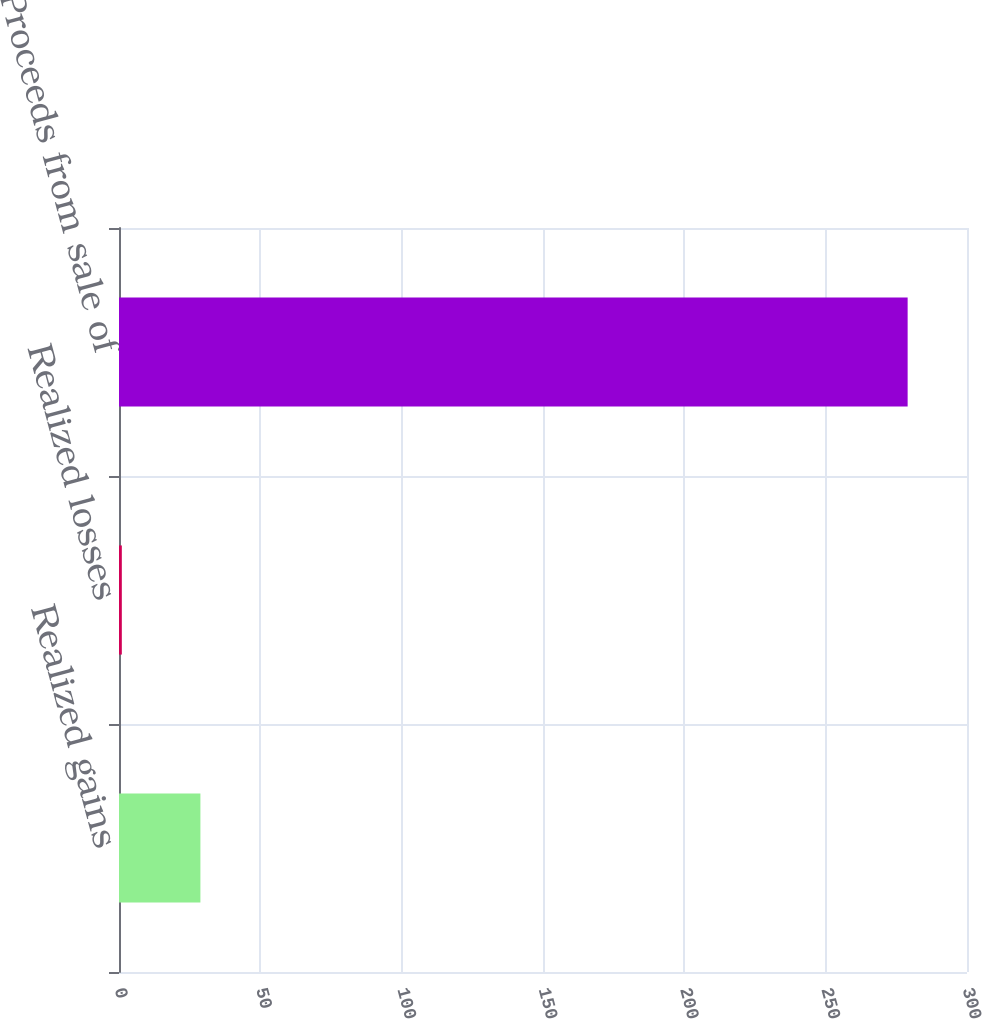Convert chart. <chart><loc_0><loc_0><loc_500><loc_500><bar_chart><fcel>Realized gains<fcel>Realized losses<fcel>Proceeds from sale of<nl><fcel>28.8<fcel>1<fcel>279<nl></chart> 